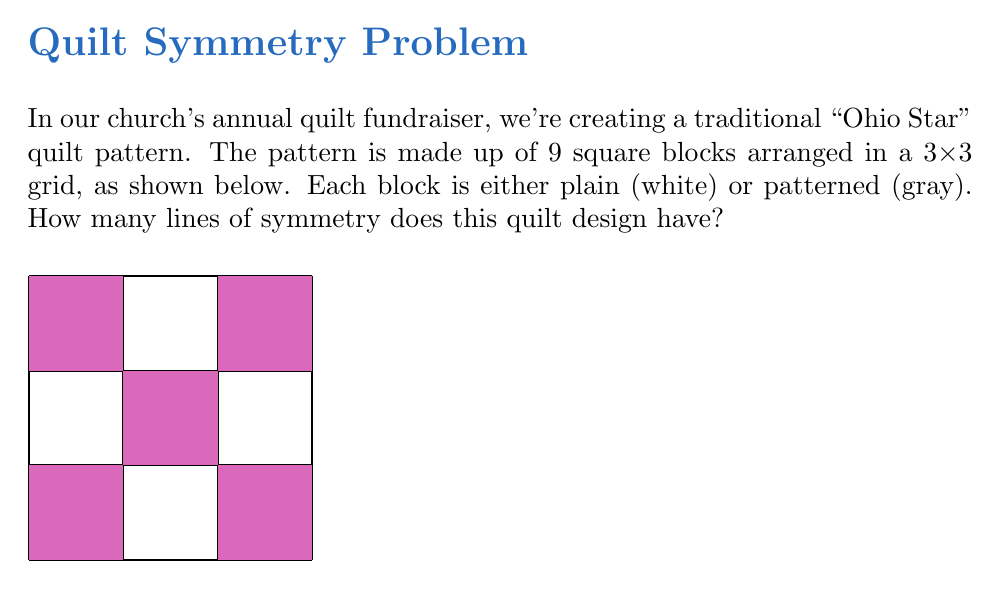Help me with this question. Let's approach this step-by-step:

1) First, we need to understand what symmetry means in this context. A line of symmetry divides the quilt into two identical halves, where one half is a mirror image of the other.

2) In a square design like this, we can have two types of symmetry lines:
   - Diagonal lines (from corner to corner)
   - Lines through the middle (vertical or horizontal)

3) Let's check for diagonal symmetry:
   - From top-left to bottom-right: This is a line of symmetry. The pattern is the same on both sides.
   - From top-right to bottom-left: This is also a line of symmetry.

4) Now, let's check for middle lines:
   - Vertical middle line: This divides the quilt into two identical halves.
   - Horizontal middle line: This also divides the quilt into two identical halves.

5) To confirm, let's count the patterned (gray) squares on each side of these lines:
   - For diagonal lines: 2 on each side
   - For middle lines: 2 on each side and 1 on the line itself

6) Therefore, we have found 4 lines of symmetry in total:
   - 2 diagonal lines
   - 1 vertical middle line
   - 1 horizontal middle line

This high degree of symmetry is common in traditional quilt designs, reflecting the orderly and balanced values often associated with small-town, conservative communities.
Answer: 4 